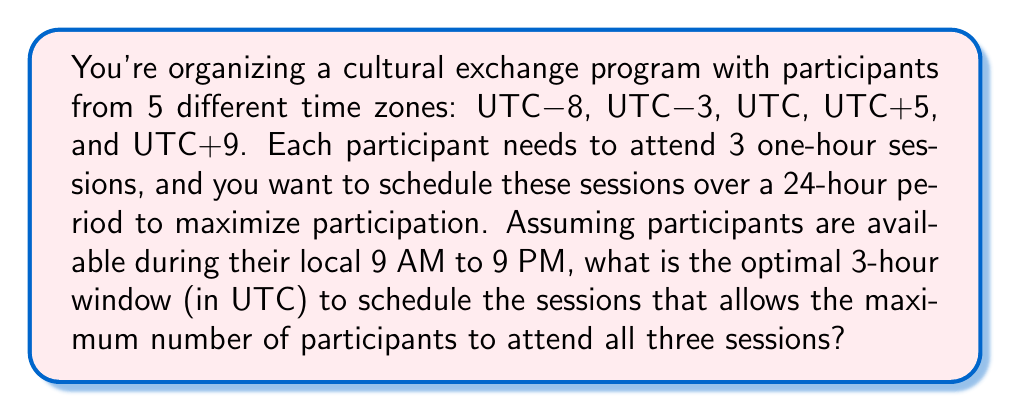Give your solution to this math problem. Let's approach this problem step-by-step:

1) First, we need to convert the local 9 AM to 9 PM availability for each time zone to UTC:

   UTC-8: 17:00 - 05:00 UTC
   UTC-3: 12:00 - 00:00 UTC
   UTC:   09:00 - 21:00 UTC
   UTC+5: 04:00 - 16:00 UTC
   UTC+9: 00:00 - 12:00 UTC

2) Now, we need to find the overlap of these time ranges. The overlap starts at the latest start time (17:00 UTC) and ends at the earliest end time (12:00 UTC the next day).

3) We can represent this visually:

   [asy]
   unitsize(1cm);
   for(int i=0; i<5; ++i) {
     draw((0,i)--(19,i),black);
   }
   draw((7,0)--(19,0),red);
   draw((3,1)--(19,1),red);
   draw((0,2)--(12,2),red);
   draw((0,3)--(7,3),red);
   draw((0,4)--(3,4),red);
   label("UTC-8",(-1,0),E);
   label("UTC-3",(-1,1),E);
   label("UTC",(-1,2),E);
   label("UTC+5",(-1,3),E);
   label("UTC+9",(-1,4),E);
   for(int i=0; i<20; ++i) {
     label(string(i),1.2*(i,-1),S);
   }
   label("17:00",(7,-1),S);
   label("12:00",(12,-1),S);
   [/asy]

4) The optimal window should be within this overlap period (17:00 - 12:00 UTC).

5) To maximize participation, we should choose the 3-hour window that includes the most time zones. This occurs from 17:00 to 20:00 UTC, which includes all time zones except UTC+9.

6) While a later time might include UTC+9, it would exclude more western time zones, resulting in less overall participation.

Therefore, the optimal 3-hour window is 17:00 to 20:00 UTC.
Answer: The optimal 3-hour window to schedule the sessions is 17:00 to 20:00 UTC. 